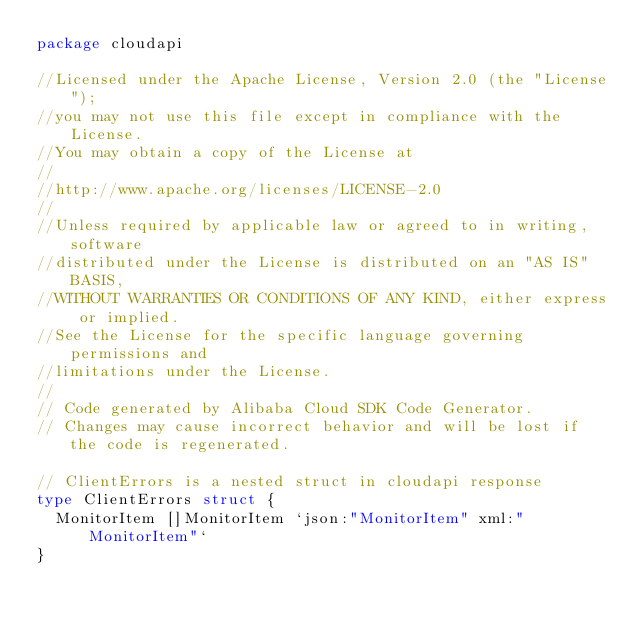<code> <loc_0><loc_0><loc_500><loc_500><_Go_>package cloudapi

//Licensed under the Apache License, Version 2.0 (the "License");
//you may not use this file except in compliance with the License.
//You may obtain a copy of the License at
//
//http://www.apache.org/licenses/LICENSE-2.0
//
//Unless required by applicable law or agreed to in writing, software
//distributed under the License is distributed on an "AS IS" BASIS,
//WITHOUT WARRANTIES OR CONDITIONS OF ANY KIND, either express or implied.
//See the License for the specific language governing permissions and
//limitations under the License.
//
// Code generated by Alibaba Cloud SDK Code Generator.
// Changes may cause incorrect behavior and will be lost if the code is regenerated.

// ClientErrors is a nested struct in cloudapi response
type ClientErrors struct {
	MonitorItem []MonitorItem `json:"MonitorItem" xml:"MonitorItem"`
}
</code> 